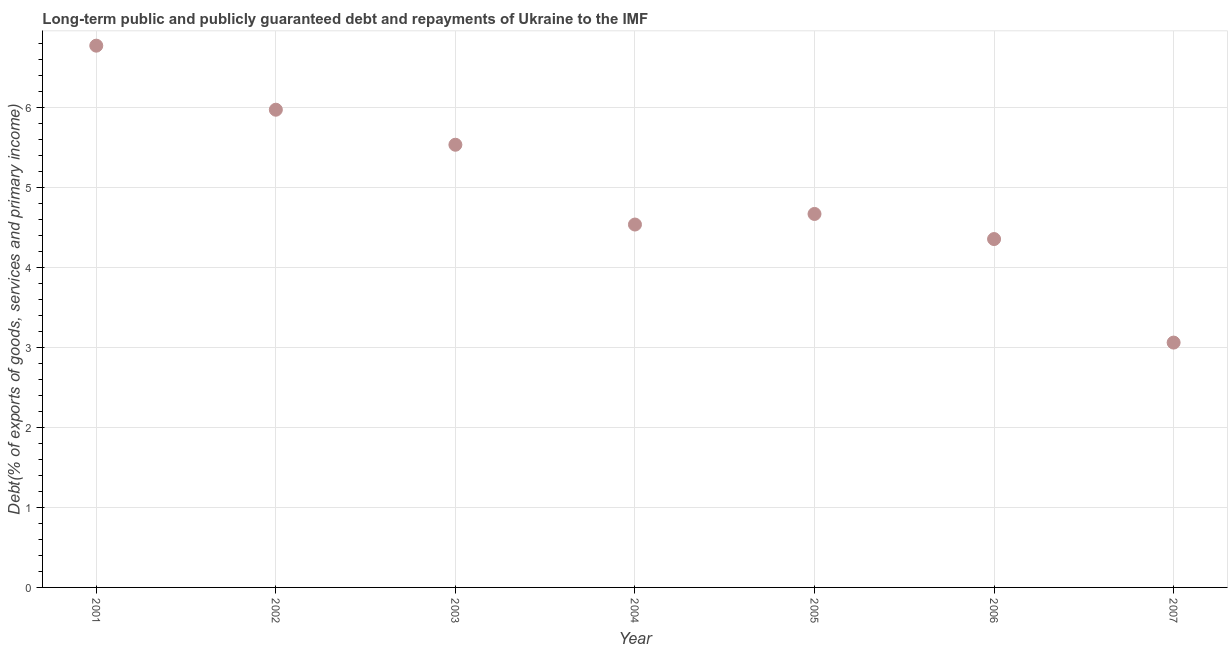What is the debt service in 2003?
Keep it short and to the point. 5.53. Across all years, what is the maximum debt service?
Your response must be concise. 6.77. Across all years, what is the minimum debt service?
Your answer should be very brief. 3.06. In which year was the debt service maximum?
Provide a short and direct response. 2001. What is the sum of the debt service?
Offer a terse response. 34.9. What is the difference between the debt service in 2006 and 2007?
Keep it short and to the point. 1.29. What is the average debt service per year?
Your answer should be compact. 4.99. What is the median debt service?
Keep it short and to the point. 4.67. What is the ratio of the debt service in 2003 to that in 2004?
Keep it short and to the point. 1.22. Is the debt service in 2001 less than that in 2007?
Your answer should be compact. No. Is the difference between the debt service in 2005 and 2006 greater than the difference between any two years?
Keep it short and to the point. No. What is the difference between the highest and the second highest debt service?
Give a very brief answer. 0.8. Is the sum of the debt service in 2003 and 2006 greater than the maximum debt service across all years?
Offer a terse response. Yes. What is the difference between the highest and the lowest debt service?
Ensure brevity in your answer.  3.71. In how many years, is the debt service greater than the average debt service taken over all years?
Give a very brief answer. 3. Does the debt service monotonically increase over the years?
Provide a short and direct response. No. How many dotlines are there?
Give a very brief answer. 1. How many years are there in the graph?
Make the answer very short. 7. Does the graph contain any zero values?
Keep it short and to the point. No. Does the graph contain grids?
Make the answer very short. Yes. What is the title of the graph?
Ensure brevity in your answer.  Long-term public and publicly guaranteed debt and repayments of Ukraine to the IMF. What is the label or title of the Y-axis?
Provide a short and direct response. Debt(% of exports of goods, services and primary income). What is the Debt(% of exports of goods, services and primary income) in 2001?
Your answer should be very brief. 6.77. What is the Debt(% of exports of goods, services and primary income) in 2002?
Your answer should be compact. 5.97. What is the Debt(% of exports of goods, services and primary income) in 2003?
Ensure brevity in your answer.  5.53. What is the Debt(% of exports of goods, services and primary income) in 2004?
Make the answer very short. 4.54. What is the Debt(% of exports of goods, services and primary income) in 2005?
Keep it short and to the point. 4.67. What is the Debt(% of exports of goods, services and primary income) in 2006?
Provide a succinct answer. 4.36. What is the Debt(% of exports of goods, services and primary income) in 2007?
Keep it short and to the point. 3.06. What is the difference between the Debt(% of exports of goods, services and primary income) in 2001 and 2002?
Your answer should be compact. 0.8. What is the difference between the Debt(% of exports of goods, services and primary income) in 2001 and 2003?
Offer a very short reply. 1.24. What is the difference between the Debt(% of exports of goods, services and primary income) in 2001 and 2004?
Your answer should be compact. 2.24. What is the difference between the Debt(% of exports of goods, services and primary income) in 2001 and 2005?
Your answer should be compact. 2.1. What is the difference between the Debt(% of exports of goods, services and primary income) in 2001 and 2006?
Provide a short and direct response. 2.42. What is the difference between the Debt(% of exports of goods, services and primary income) in 2001 and 2007?
Your answer should be compact. 3.71. What is the difference between the Debt(% of exports of goods, services and primary income) in 2002 and 2003?
Offer a terse response. 0.44. What is the difference between the Debt(% of exports of goods, services and primary income) in 2002 and 2004?
Your answer should be compact. 1.44. What is the difference between the Debt(% of exports of goods, services and primary income) in 2002 and 2005?
Offer a very short reply. 1.3. What is the difference between the Debt(% of exports of goods, services and primary income) in 2002 and 2006?
Your answer should be very brief. 1.62. What is the difference between the Debt(% of exports of goods, services and primary income) in 2002 and 2007?
Make the answer very short. 2.91. What is the difference between the Debt(% of exports of goods, services and primary income) in 2003 and 2004?
Your answer should be compact. 1. What is the difference between the Debt(% of exports of goods, services and primary income) in 2003 and 2005?
Offer a terse response. 0.87. What is the difference between the Debt(% of exports of goods, services and primary income) in 2003 and 2006?
Your response must be concise. 1.18. What is the difference between the Debt(% of exports of goods, services and primary income) in 2003 and 2007?
Give a very brief answer. 2.47. What is the difference between the Debt(% of exports of goods, services and primary income) in 2004 and 2005?
Provide a succinct answer. -0.13. What is the difference between the Debt(% of exports of goods, services and primary income) in 2004 and 2006?
Your answer should be compact. 0.18. What is the difference between the Debt(% of exports of goods, services and primary income) in 2004 and 2007?
Your response must be concise. 1.48. What is the difference between the Debt(% of exports of goods, services and primary income) in 2005 and 2006?
Your response must be concise. 0.31. What is the difference between the Debt(% of exports of goods, services and primary income) in 2005 and 2007?
Offer a very short reply. 1.61. What is the difference between the Debt(% of exports of goods, services and primary income) in 2006 and 2007?
Your answer should be compact. 1.29. What is the ratio of the Debt(% of exports of goods, services and primary income) in 2001 to that in 2002?
Your answer should be very brief. 1.13. What is the ratio of the Debt(% of exports of goods, services and primary income) in 2001 to that in 2003?
Ensure brevity in your answer.  1.22. What is the ratio of the Debt(% of exports of goods, services and primary income) in 2001 to that in 2004?
Keep it short and to the point. 1.49. What is the ratio of the Debt(% of exports of goods, services and primary income) in 2001 to that in 2005?
Provide a short and direct response. 1.45. What is the ratio of the Debt(% of exports of goods, services and primary income) in 2001 to that in 2006?
Give a very brief answer. 1.55. What is the ratio of the Debt(% of exports of goods, services and primary income) in 2001 to that in 2007?
Your answer should be very brief. 2.21. What is the ratio of the Debt(% of exports of goods, services and primary income) in 2002 to that in 2003?
Keep it short and to the point. 1.08. What is the ratio of the Debt(% of exports of goods, services and primary income) in 2002 to that in 2004?
Ensure brevity in your answer.  1.32. What is the ratio of the Debt(% of exports of goods, services and primary income) in 2002 to that in 2005?
Offer a terse response. 1.28. What is the ratio of the Debt(% of exports of goods, services and primary income) in 2002 to that in 2006?
Your answer should be compact. 1.37. What is the ratio of the Debt(% of exports of goods, services and primary income) in 2002 to that in 2007?
Your answer should be very brief. 1.95. What is the ratio of the Debt(% of exports of goods, services and primary income) in 2003 to that in 2004?
Provide a short and direct response. 1.22. What is the ratio of the Debt(% of exports of goods, services and primary income) in 2003 to that in 2005?
Your response must be concise. 1.19. What is the ratio of the Debt(% of exports of goods, services and primary income) in 2003 to that in 2006?
Offer a terse response. 1.27. What is the ratio of the Debt(% of exports of goods, services and primary income) in 2003 to that in 2007?
Offer a very short reply. 1.81. What is the ratio of the Debt(% of exports of goods, services and primary income) in 2004 to that in 2005?
Your answer should be very brief. 0.97. What is the ratio of the Debt(% of exports of goods, services and primary income) in 2004 to that in 2006?
Ensure brevity in your answer.  1.04. What is the ratio of the Debt(% of exports of goods, services and primary income) in 2004 to that in 2007?
Your answer should be compact. 1.48. What is the ratio of the Debt(% of exports of goods, services and primary income) in 2005 to that in 2006?
Provide a succinct answer. 1.07. What is the ratio of the Debt(% of exports of goods, services and primary income) in 2005 to that in 2007?
Offer a very short reply. 1.52. What is the ratio of the Debt(% of exports of goods, services and primary income) in 2006 to that in 2007?
Offer a terse response. 1.42. 